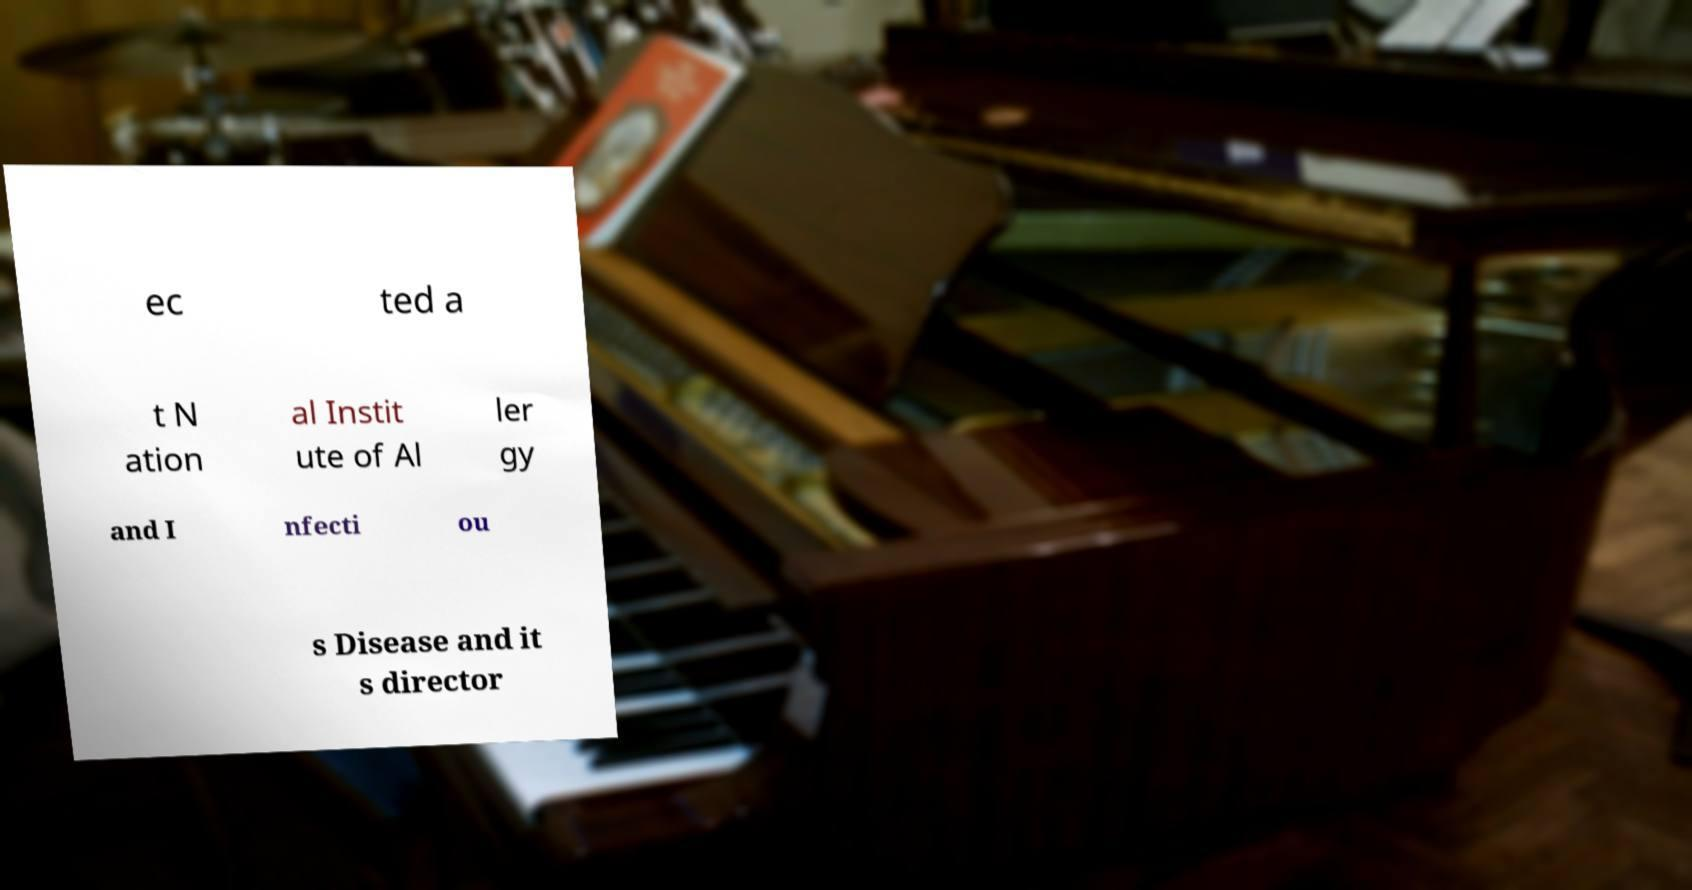For documentation purposes, I need the text within this image transcribed. Could you provide that? ec ted a t N ation al Instit ute of Al ler gy and I nfecti ou s Disease and it s director 